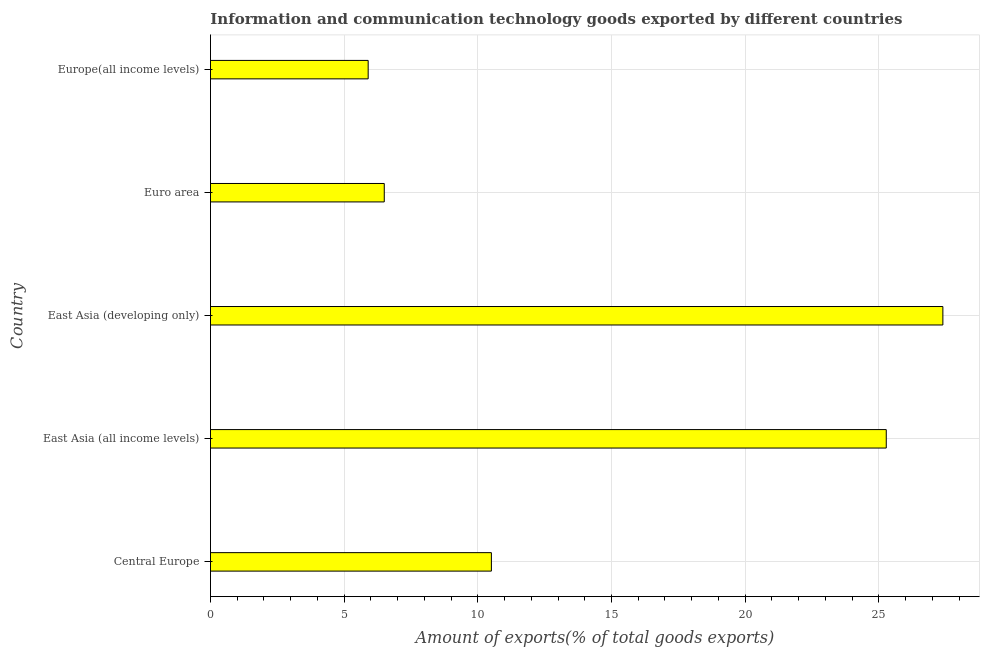Does the graph contain any zero values?
Offer a terse response. No. What is the title of the graph?
Your answer should be very brief. Information and communication technology goods exported by different countries. What is the label or title of the X-axis?
Your response must be concise. Amount of exports(% of total goods exports). What is the label or title of the Y-axis?
Keep it short and to the point. Country. What is the amount of ict goods exports in East Asia (all income levels)?
Your answer should be compact. 25.28. Across all countries, what is the maximum amount of ict goods exports?
Provide a succinct answer. 27.4. Across all countries, what is the minimum amount of ict goods exports?
Ensure brevity in your answer.  5.9. In which country was the amount of ict goods exports maximum?
Provide a succinct answer. East Asia (developing only). In which country was the amount of ict goods exports minimum?
Make the answer very short. Europe(all income levels). What is the sum of the amount of ict goods exports?
Provide a short and direct response. 75.58. What is the difference between the amount of ict goods exports in Central Europe and Europe(all income levels)?
Give a very brief answer. 4.61. What is the average amount of ict goods exports per country?
Give a very brief answer. 15.12. What is the median amount of ict goods exports?
Ensure brevity in your answer.  10.51. What is the ratio of the amount of ict goods exports in Central Europe to that in Europe(all income levels)?
Provide a succinct answer. 1.78. Is the difference between the amount of ict goods exports in East Asia (developing only) and Europe(all income levels) greater than the difference between any two countries?
Provide a short and direct response. Yes. What is the difference between the highest and the second highest amount of ict goods exports?
Provide a succinct answer. 2.12. What is the difference between the highest and the lowest amount of ict goods exports?
Keep it short and to the point. 21.5. How many bars are there?
Keep it short and to the point. 5. What is the Amount of exports(% of total goods exports) in Central Europe?
Offer a terse response. 10.51. What is the Amount of exports(% of total goods exports) in East Asia (all income levels)?
Give a very brief answer. 25.28. What is the Amount of exports(% of total goods exports) in East Asia (developing only)?
Your answer should be compact. 27.4. What is the Amount of exports(% of total goods exports) in Euro area?
Keep it short and to the point. 6.5. What is the Amount of exports(% of total goods exports) in Europe(all income levels)?
Make the answer very short. 5.9. What is the difference between the Amount of exports(% of total goods exports) in Central Europe and East Asia (all income levels)?
Give a very brief answer. -14.77. What is the difference between the Amount of exports(% of total goods exports) in Central Europe and East Asia (developing only)?
Offer a very short reply. -16.89. What is the difference between the Amount of exports(% of total goods exports) in Central Europe and Euro area?
Your response must be concise. 4.01. What is the difference between the Amount of exports(% of total goods exports) in Central Europe and Europe(all income levels)?
Your response must be concise. 4.61. What is the difference between the Amount of exports(% of total goods exports) in East Asia (all income levels) and East Asia (developing only)?
Offer a terse response. -2.12. What is the difference between the Amount of exports(% of total goods exports) in East Asia (all income levels) and Euro area?
Ensure brevity in your answer.  18.78. What is the difference between the Amount of exports(% of total goods exports) in East Asia (all income levels) and Europe(all income levels)?
Your answer should be compact. 19.38. What is the difference between the Amount of exports(% of total goods exports) in East Asia (developing only) and Euro area?
Make the answer very short. 20.9. What is the difference between the Amount of exports(% of total goods exports) in East Asia (developing only) and Europe(all income levels)?
Offer a terse response. 21.5. What is the difference between the Amount of exports(% of total goods exports) in Euro area and Europe(all income levels)?
Give a very brief answer. 0.6. What is the ratio of the Amount of exports(% of total goods exports) in Central Europe to that in East Asia (all income levels)?
Give a very brief answer. 0.42. What is the ratio of the Amount of exports(% of total goods exports) in Central Europe to that in East Asia (developing only)?
Your answer should be very brief. 0.38. What is the ratio of the Amount of exports(% of total goods exports) in Central Europe to that in Euro area?
Keep it short and to the point. 1.62. What is the ratio of the Amount of exports(% of total goods exports) in Central Europe to that in Europe(all income levels)?
Offer a terse response. 1.78. What is the ratio of the Amount of exports(% of total goods exports) in East Asia (all income levels) to that in East Asia (developing only)?
Your answer should be compact. 0.92. What is the ratio of the Amount of exports(% of total goods exports) in East Asia (all income levels) to that in Euro area?
Keep it short and to the point. 3.89. What is the ratio of the Amount of exports(% of total goods exports) in East Asia (all income levels) to that in Europe(all income levels)?
Give a very brief answer. 4.29. What is the ratio of the Amount of exports(% of total goods exports) in East Asia (developing only) to that in Euro area?
Your response must be concise. 4.21. What is the ratio of the Amount of exports(% of total goods exports) in East Asia (developing only) to that in Europe(all income levels)?
Give a very brief answer. 4.64. What is the ratio of the Amount of exports(% of total goods exports) in Euro area to that in Europe(all income levels)?
Provide a succinct answer. 1.1. 